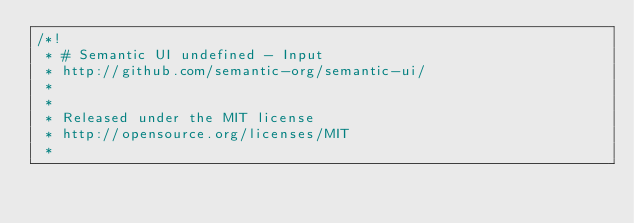Convert code to text. <code><loc_0><loc_0><loc_500><loc_500><_CSS_>/*!
 * # Semantic UI undefined - Input
 * http://github.com/semantic-org/semantic-ui/
 *
 *
 * Released under the MIT license
 * http://opensource.org/licenses/MIT
 *</code> 